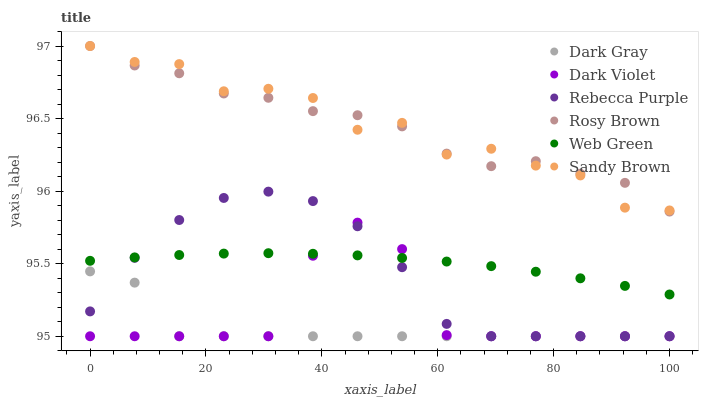Does Dark Gray have the minimum area under the curve?
Answer yes or no. Yes. Does Sandy Brown have the maximum area under the curve?
Answer yes or no. Yes. Does Rosy Brown have the minimum area under the curve?
Answer yes or no. No. Does Rosy Brown have the maximum area under the curve?
Answer yes or no. No. Is Web Green the smoothest?
Answer yes or no. Yes. Is Dark Violet the roughest?
Answer yes or no. Yes. Is Rosy Brown the smoothest?
Answer yes or no. No. Is Rosy Brown the roughest?
Answer yes or no. No. Does Dark Violet have the lowest value?
Answer yes or no. Yes. Does Rosy Brown have the lowest value?
Answer yes or no. No. Does Sandy Brown have the highest value?
Answer yes or no. Yes. Does Web Green have the highest value?
Answer yes or no. No. Is Dark Gray less than Sandy Brown?
Answer yes or no. Yes. Is Sandy Brown greater than Dark Gray?
Answer yes or no. Yes. Does Dark Violet intersect Web Green?
Answer yes or no. Yes. Is Dark Violet less than Web Green?
Answer yes or no. No. Is Dark Violet greater than Web Green?
Answer yes or no. No. Does Dark Gray intersect Sandy Brown?
Answer yes or no. No. 